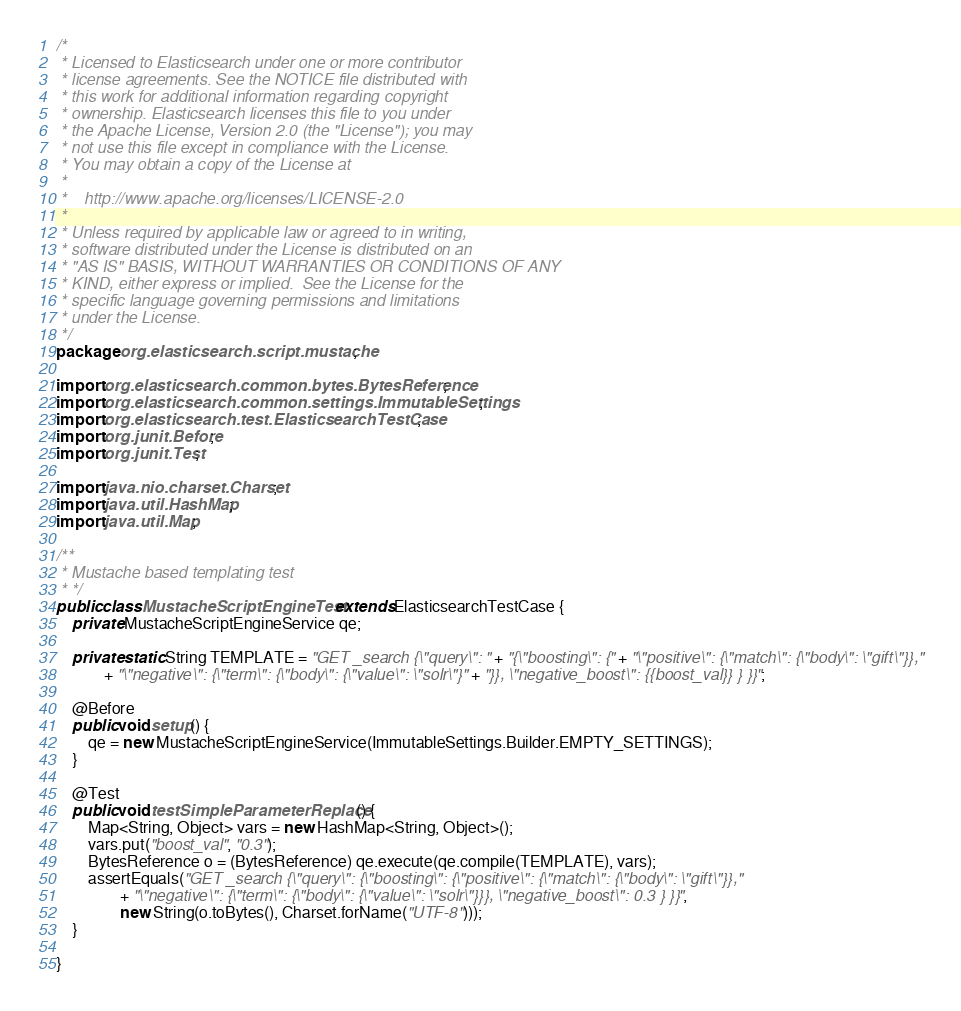<code> <loc_0><loc_0><loc_500><loc_500><_Java_>/*
 * Licensed to Elasticsearch under one or more contributor
 * license agreements. See the NOTICE file distributed with
 * this work for additional information regarding copyright
 * ownership. Elasticsearch licenses this file to you under
 * the Apache License, Version 2.0 (the "License"); you may
 * not use this file except in compliance with the License.
 * You may obtain a copy of the License at
 *
 *    http://www.apache.org/licenses/LICENSE-2.0
 *
 * Unless required by applicable law or agreed to in writing,
 * software distributed under the License is distributed on an
 * "AS IS" BASIS, WITHOUT WARRANTIES OR CONDITIONS OF ANY
 * KIND, either express or implied.  See the License for the
 * specific language governing permissions and limitations
 * under the License.
 */
package org.elasticsearch.script.mustache;

import org.elasticsearch.common.bytes.BytesReference;
import org.elasticsearch.common.settings.ImmutableSettings;
import org.elasticsearch.test.ElasticsearchTestCase;
import org.junit.Before;
import org.junit.Test;

import java.nio.charset.Charset;
import java.util.HashMap;
import java.util.Map;

/**
 * Mustache based templating test
 * */
public class MustacheScriptEngineTest extends ElasticsearchTestCase {
    private MustacheScriptEngineService qe;

    private static String TEMPLATE = "GET _search {\"query\": " + "{\"boosting\": {" + "\"positive\": {\"match\": {\"body\": \"gift\"}},"
            + "\"negative\": {\"term\": {\"body\": {\"value\": \"solr\"}" + "}}, \"negative_boost\": {{boost_val}} } }}";

    @Before
    public void setup() {
        qe = new MustacheScriptEngineService(ImmutableSettings.Builder.EMPTY_SETTINGS);
    }

    @Test
    public void testSimpleParameterReplace() {
        Map<String, Object> vars = new HashMap<String, Object>();
        vars.put("boost_val", "0.3");
        BytesReference o = (BytesReference) qe.execute(qe.compile(TEMPLATE), vars);
        assertEquals("GET _search {\"query\": {\"boosting\": {\"positive\": {\"match\": {\"body\": \"gift\"}},"
                + "\"negative\": {\"term\": {\"body\": {\"value\": \"solr\"}}}, \"negative_boost\": 0.3 } }}",
                new String(o.toBytes(), Charset.forName("UTF-8")));
    }

}
</code> 